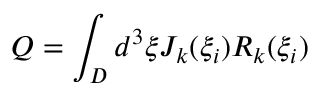Convert formula to latex. <formula><loc_0><loc_0><loc_500><loc_500>Q = \int _ { D } d ^ { 3 } \xi J _ { k } ( \xi _ { i } ) R _ { k } ( \xi _ { i } )</formula> 